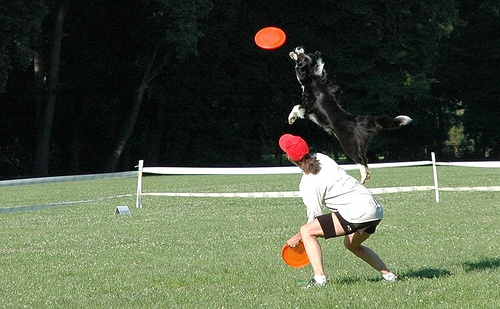Describe the objects in this image and their specific colors. I can see people in black, white, gray, and maroon tones, dog in black, gray, white, and darkgray tones, frisbee in black, red, salmon, and brown tones, and frisbee in black, red, brown, orange, and maroon tones in this image. 